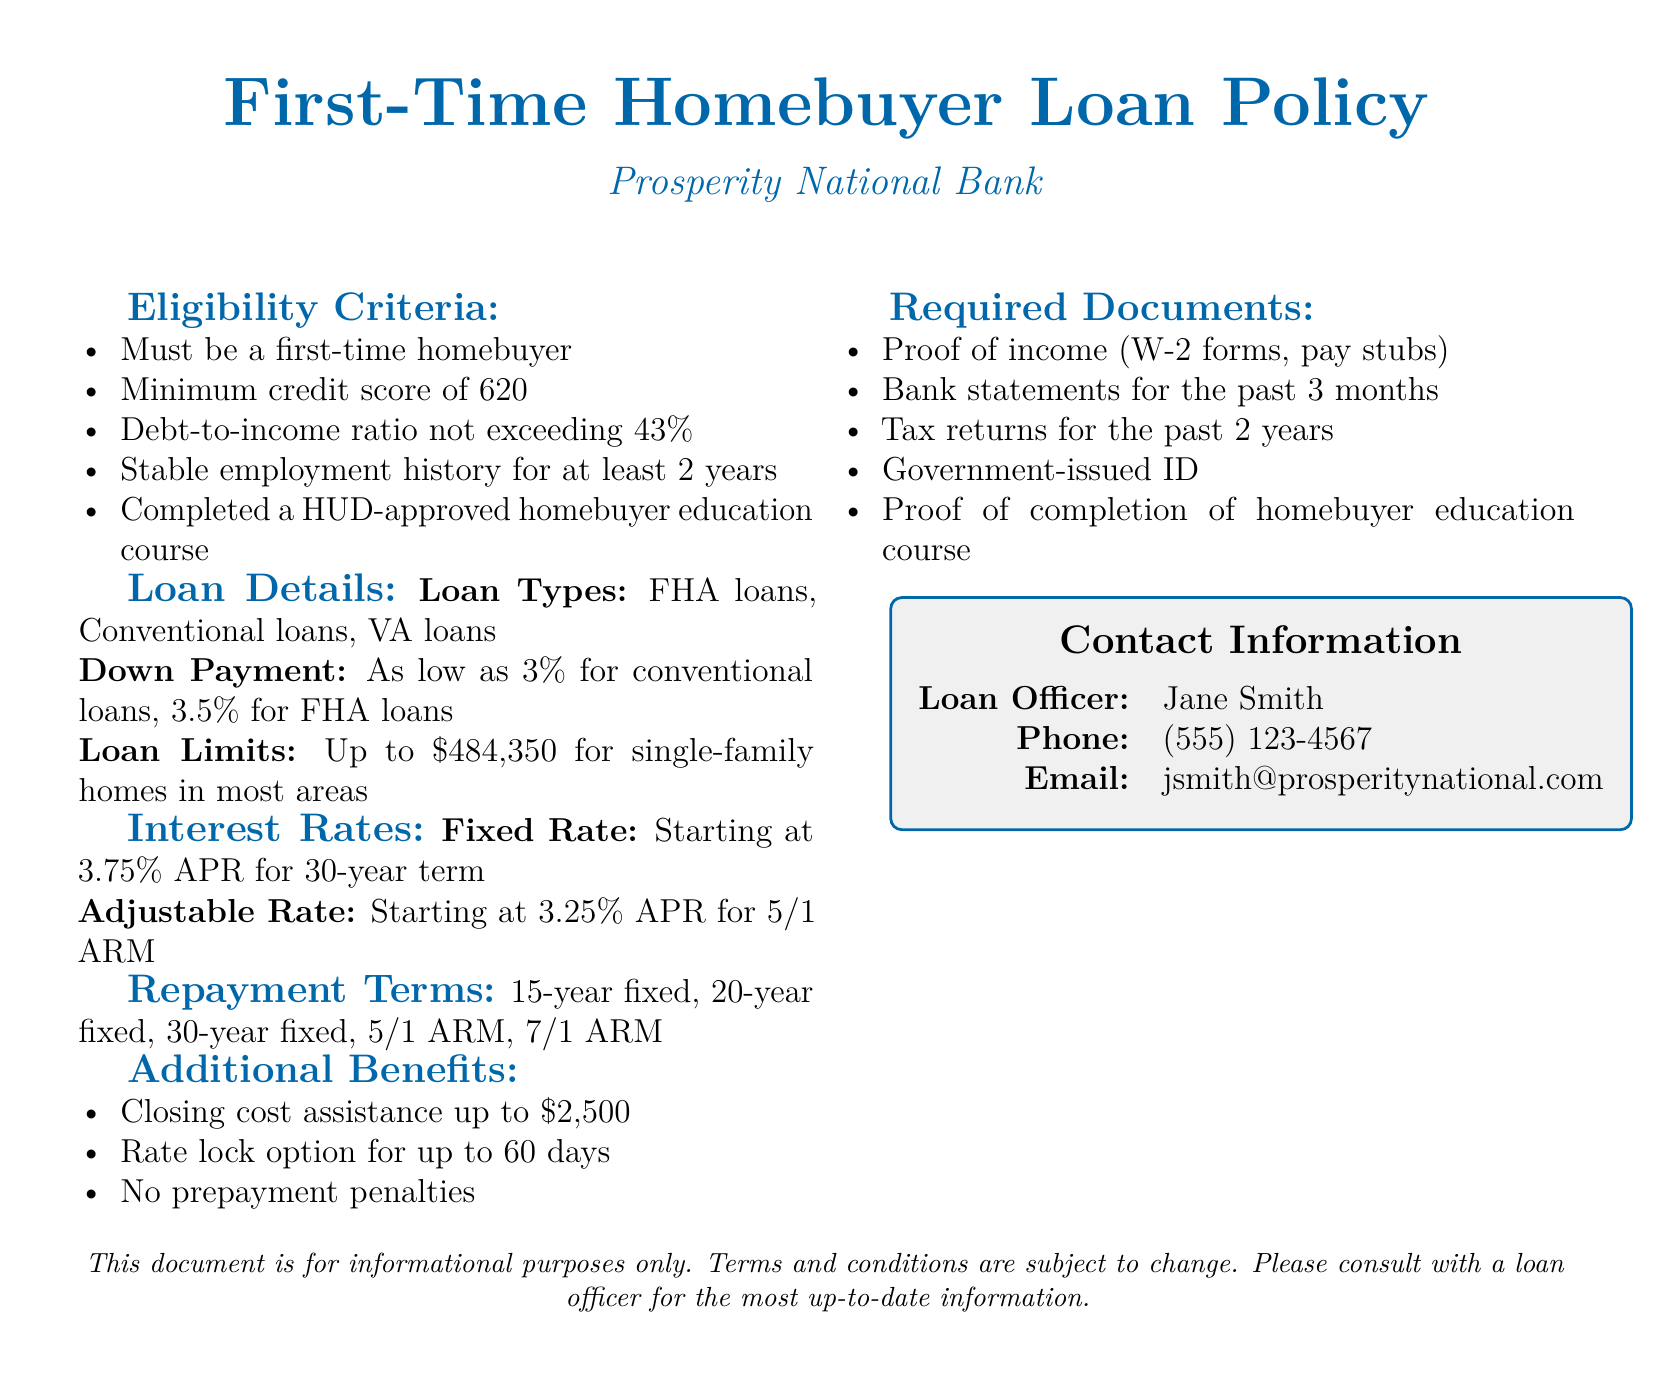What is the minimum credit score required? The document specifies that a minimum credit score of 620 is required for eligibility.
Answer: 620 What is the maximum debt-to-income ratio allowed? According to the policy, the debt-to-income ratio must not exceed 43%.
Answer: 43% What is the starting interest rate for fixed-rate loans? The document states that the starting interest rate for fixed-rate loans is 3.75% APR.
Answer: 3.75% APR What types of loans are available? The policy lists FHA loans, Conventional loans, and VA loans as the available loan types.
Answer: FHA loans, Conventional loans, VA loans How much closing cost assistance can be provided? The document mentions closing cost assistance of up to $2,500.
Answer: $2,500 What course must be completed for eligibility? First-time homebuyers must complete a HUD-approved homebuyer education course as part of the eligibility criteria.
Answer: HUD-approved homebuyer education course What is the loan limit for single-family homes? The policy states that the loan limit for single-family homes is up to $484,350 in most areas.
Answer: $484,350 Who is the loan officer mentioned in the document? The loan officer listed in the document is Jane Smith.
Answer: Jane Smith What are the repayment terms available? The document provides options for 15-year fixed, 20-year fixed, 30-year fixed, 5/1 ARM, and 7/1 ARM as repayment terms.
Answer: 15-year fixed, 20-year fixed, 30-year fixed, 5/1 ARM, 7/1 ARM 